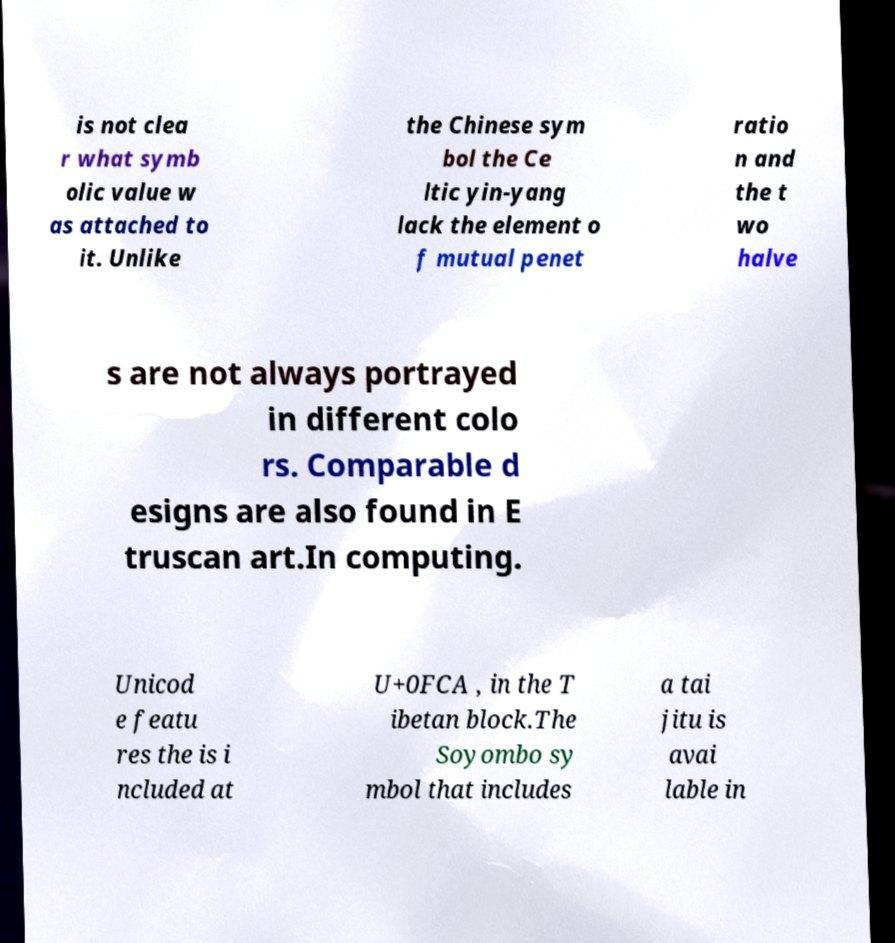Can you accurately transcribe the text from the provided image for me? is not clea r what symb olic value w as attached to it. Unlike the Chinese sym bol the Ce ltic yin-yang lack the element o f mutual penet ratio n and the t wo halve s are not always portrayed in different colo rs. Comparable d esigns are also found in E truscan art.In computing. Unicod e featu res the is i ncluded at U+0FCA , in the T ibetan block.The Soyombo sy mbol that includes a tai jitu is avai lable in 